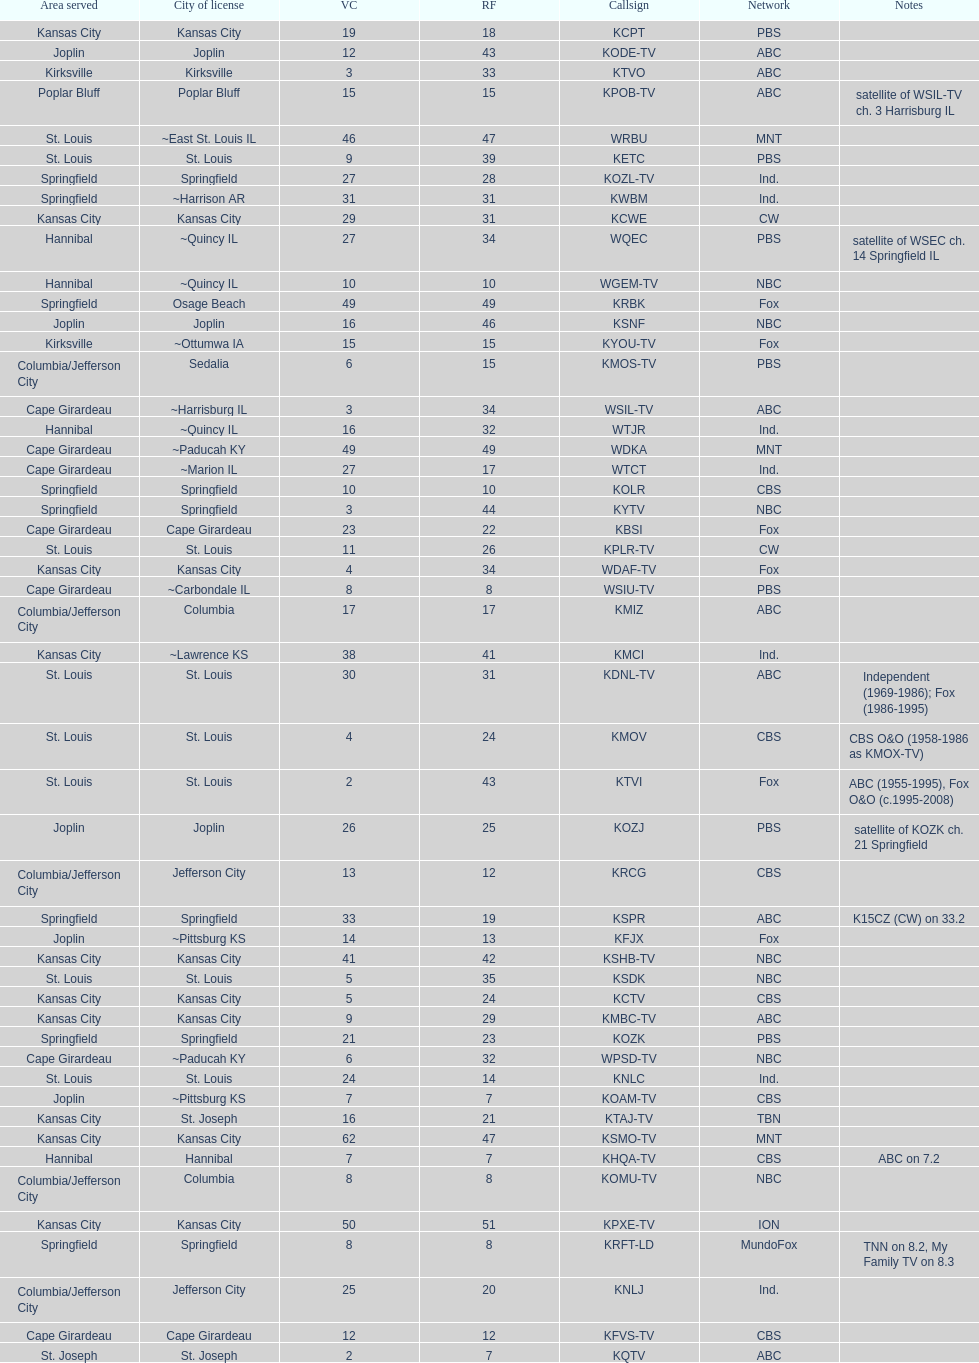What is the total number of cbs stations? 7. 